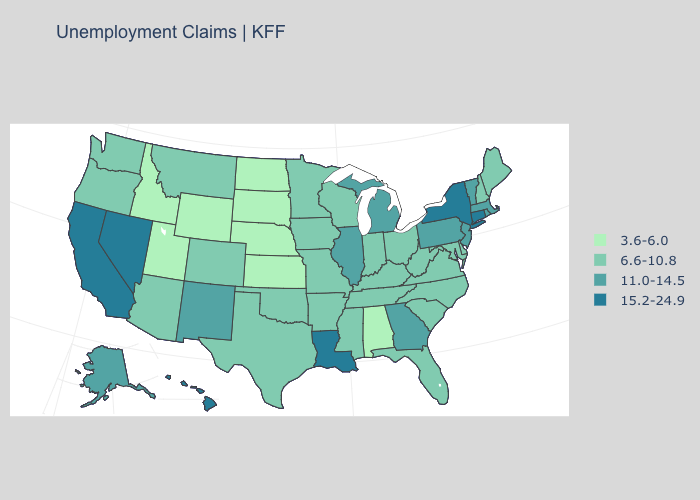Does the first symbol in the legend represent the smallest category?
Concise answer only. Yes. What is the highest value in the USA?
Concise answer only. 15.2-24.9. What is the value of New York?
Answer briefly. 15.2-24.9. Name the states that have a value in the range 15.2-24.9?
Short answer required. California, Connecticut, Hawaii, Louisiana, Nevada, New York. Which states hav the highest value in the MidWest?
Be succinct. Illinois, Michigan. Does the map have missing data?
Be succinct. No. Among the states that border Rhode Island , does Connecticut have the lowest value?
Concise answer only. No. Does Maryland have the same value as Arkansas?
Answer briefly. Yes. What is the value of Georgia?
Write a very short answer. 11.0-14.5. Name the states that have a value in the range 3.6-6.0?
Quick response, please. Alabama, Idaho, Kansas, Nebraska, North Dakota, South Dakota, Utah, Wyoming. What is the lowest value in the MidWest?
Write a very short answer. 3.6-6.0. Among the states that border Iowa , which have the lowest value?
Short answer required. Nebraska, South Dakota. What is the value of Maryland?
Write a very short answer. 6.6-10.8. Name the states that have a value in the range 15.2-24.9?
Short answer required. California, Connecticut, Hawaii, Louisiana, Nevada, New York. 